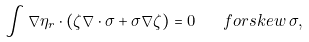Convert formula to latex. <formula><loc_0><loc_0><loc_500><loc_500>\int \nabla \eta _ { r } \cdot ( \zeta \nabla \cdot \sigma + \sigma \nabla \zeta ) = 0 \quad f o r s k e w \, \sigma ,</formula> 